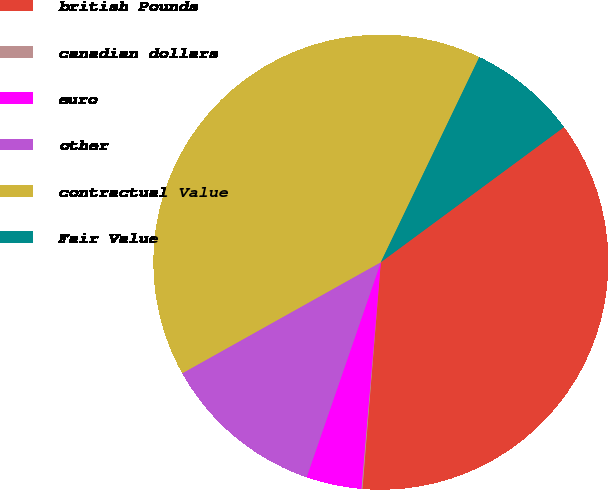Convert chart. <chart><loc_0><loc_0><loc_500><loc_500><pie_chart><fcel>british Pounds<fcel>canadian dollars<fcel>euro<fcel>other<fcel>contractual Value<fcel>Fair Value<nl><fcel>36.41%<fcel>0.08%<fcel>3.92%<fcel>11.6%<fcel>40.25%<fcel>7.76%<nl></chart> 